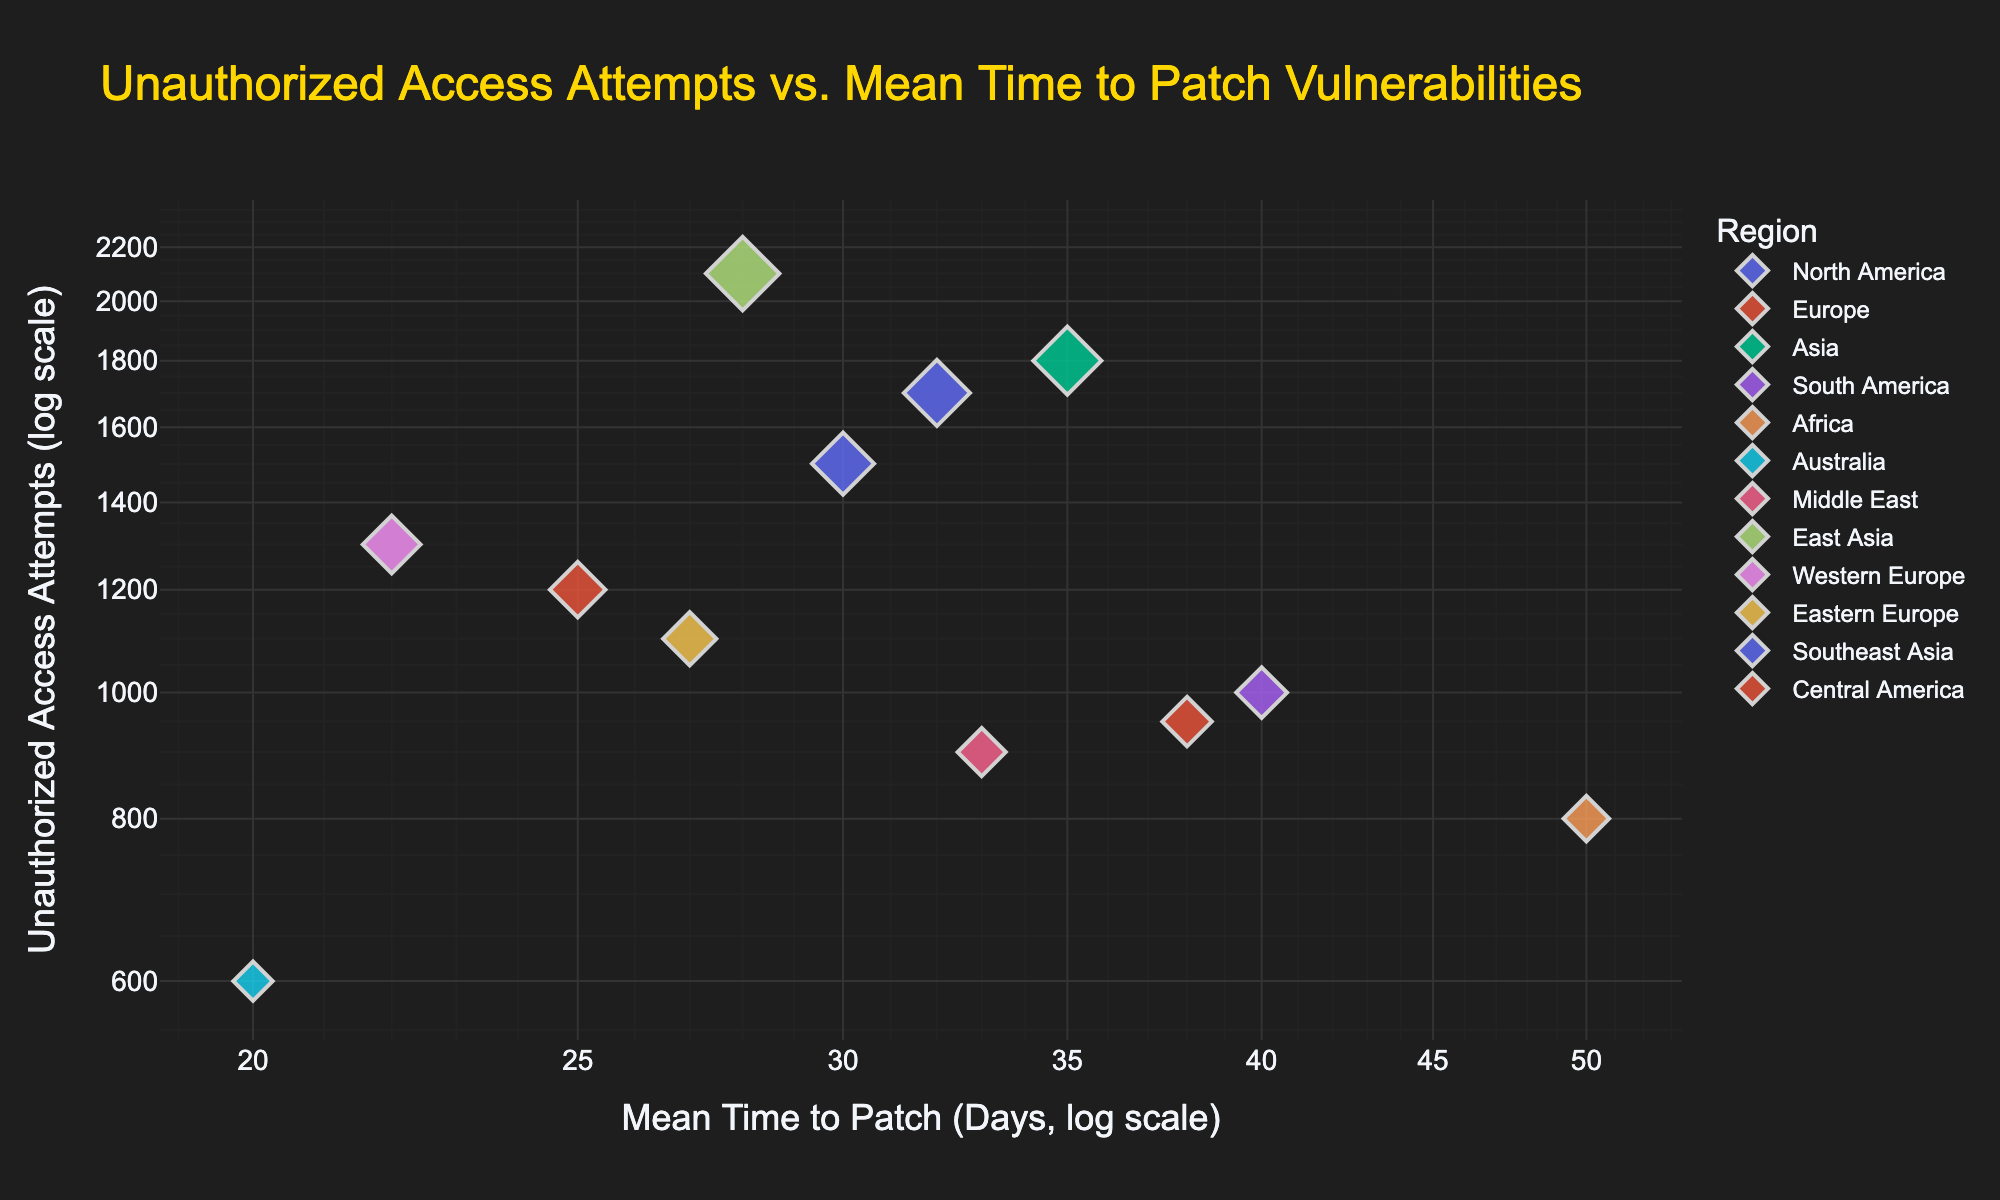What's the title of the scatter plot? The title is displayed at the top of the figure in larger font size, highlighting the main theme of the plot. The title reads "Unauthorized Access Attempts vs. Mean Time to Patch Vulnerabilities."
Answer: Unauthorized Access Attempts vs. Mean Time to Patch Vulnerabilities What regions have the highest and lowest mean time to patch vulnerabilities? By looking at the x-axis labeled "Mean Time to Patch (Days, log scale)," we can identify which points are farthest to the right (highest) and farthest to the left (lowest). Africa has the highest mean time to patch (50 days), and Australia has the lowest (20 days).
Answer: Africa and Australia Which region has the most unauthorized access attempts, and approximately how many attempts are there? By viewing the size and position of the points on the y-axis (log scale for Unauthorized Access Attempts), the largest point near the top signifies the highest number. East Asia has the most unauthorized access attempts with approximately 2100 attempts.
Answer: East Asia, 2100 How do the unauthorized access attempts for Europe compare to those for North America? Identify the data points for Europe and North America on the y-axis. North America has around 1500 unauthorized access attempts, while Europe has roughly 1200.
Answer: North America has more attempts than Europe Which region has the shortest mean time to patch vulnerabilities among those with over 1500 unauthorized access attempts? First identify regions with unauthorized access attempts greater than 1500. These are North America, Asia, East Asia, and Southeast Asia. Among them, East Asia has the shortest mean time to patch vulnerabilities at 28 days.
Answer: East Asia What is the relationship displayed between mean time to patch vulnerabilities and unauthorized access attempts? Observing the overall scatter plot trend, points tend to spread out rather than forming a clear linear relationship. There doesn't seem to be a straightforward correlation between mean time to patch vulnerabilities and unauthorized access attempts.
Answer: No clear linear relationship Are there more regions with mean time to patch vulnerabilities above or below 30 days? Looking along the x-axis, we count the number of regions on either side of the 30-day mark. Below 30 days: North America, Europe, East Asia, Australia, Western Europe, and Eastern Europe (6 regions). Above 30 days: Asia, South America, Africa, Middle East, Southeast Asia, and Central America (6 regions). Equal number of regions above and below.
Answer: Equal Which regions have both mean time to patch over 25 days and unauthorized access attempts over 1000? Scan the plot for points where both x-axis (mean time to patch) is over 25 days and y-axis (unauthorized access attempts) is over 1000. These regions are North America, Asia, East Asia, Southeast Asia, and Central America.
Answer: North America, Asia, East Asia, Southeast Asia, Central America Do regions with higher unauthorized access attempts generally have higher mean time to patch vulnerabilities? By analyzing the scatter, most regions with high unauthorized access attempts (like East Asia with 2100 and Asia with 1800) don't necessarily have the highest mean time to patch vulnerabilities. For example, East Asia has 28 days and Asia has 35 days. There isn't a consistent trend showing a direct relationship.
Answer: No, not generally Which regions have a lower mean time to patch vulnerabilities compared to North America’s mean time to patch, and fewer unauthorized access attempts? Find North America's point (30 days, 1500 attempts) as a reference. Regions with mean time to patch under 30 days and fewer than 1500 unauthorized access attempts are: Europe, Western Europe, Eastern Europe, and Australia.
Answer: Europe, Western Europe, Eastern Europe, Australia 